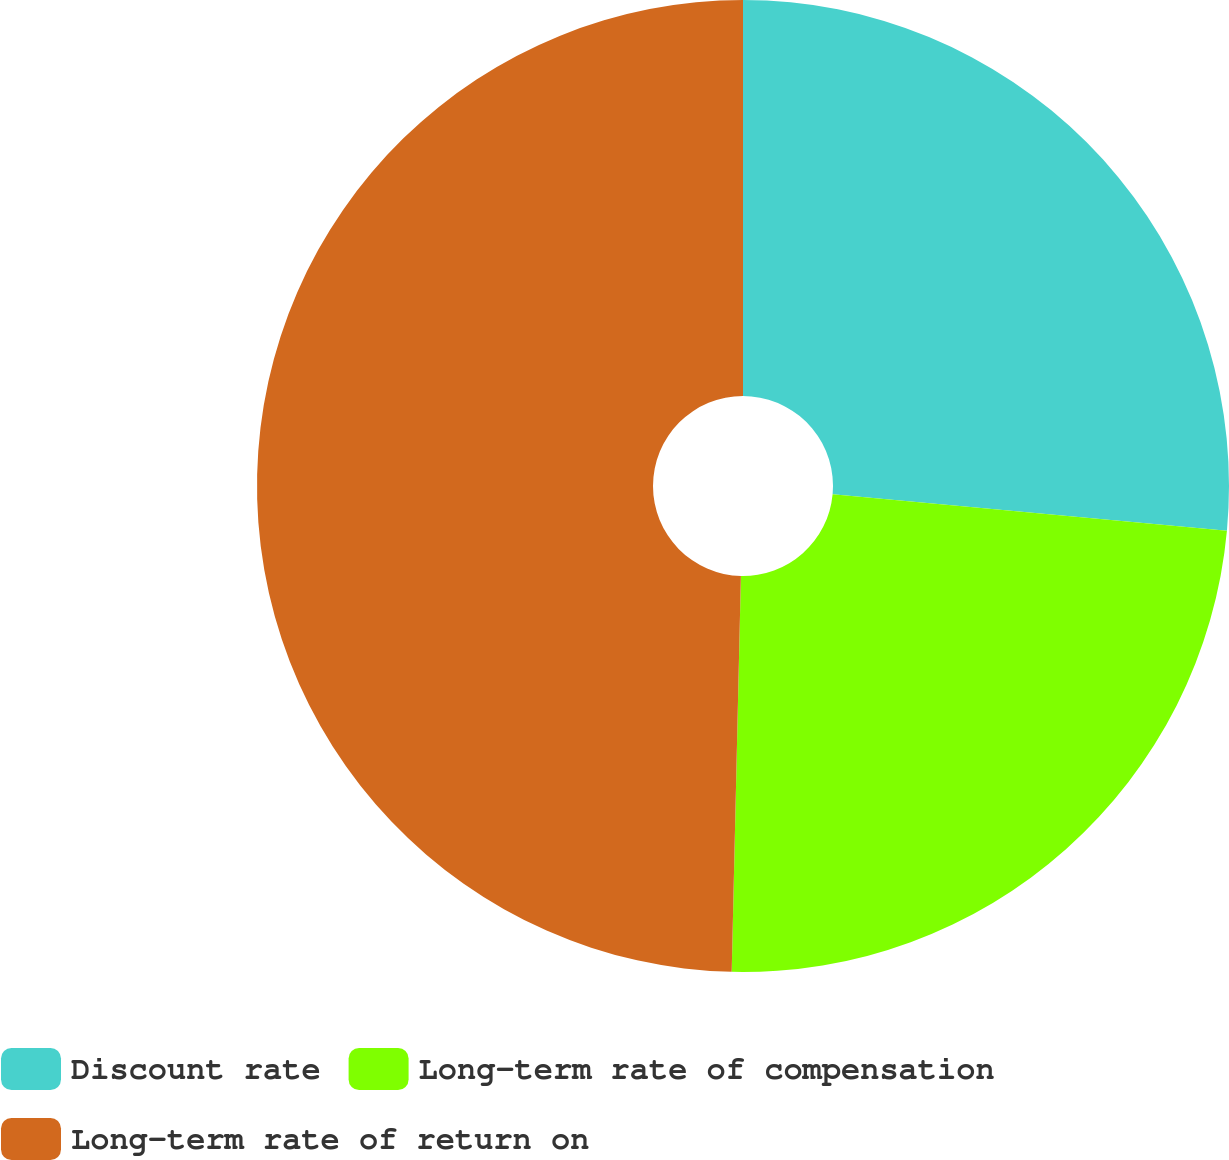Convert chart. <chart><loc_0><loc_0><loc_500><loc_500><pie_chart><fcel>Discount rate<fcel>Long-term rate of compensation<fcel>Long-term rate of return on<nl><fcel>26.47%<fcel>23.9%<fcel>49.63%<nl></chart> 